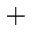Convert formula to latex. <formula><loc_0><loc_0><loc_500><loc_500>^ { + }</formula> 